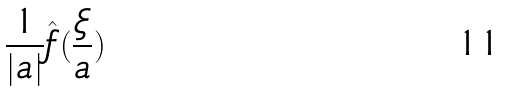<formula> <loc_0><loc_0><loc_500><loc_500>\frac { 1 } { | a | } \hat { f } ( \frac { \xi } { a } )</formula> 